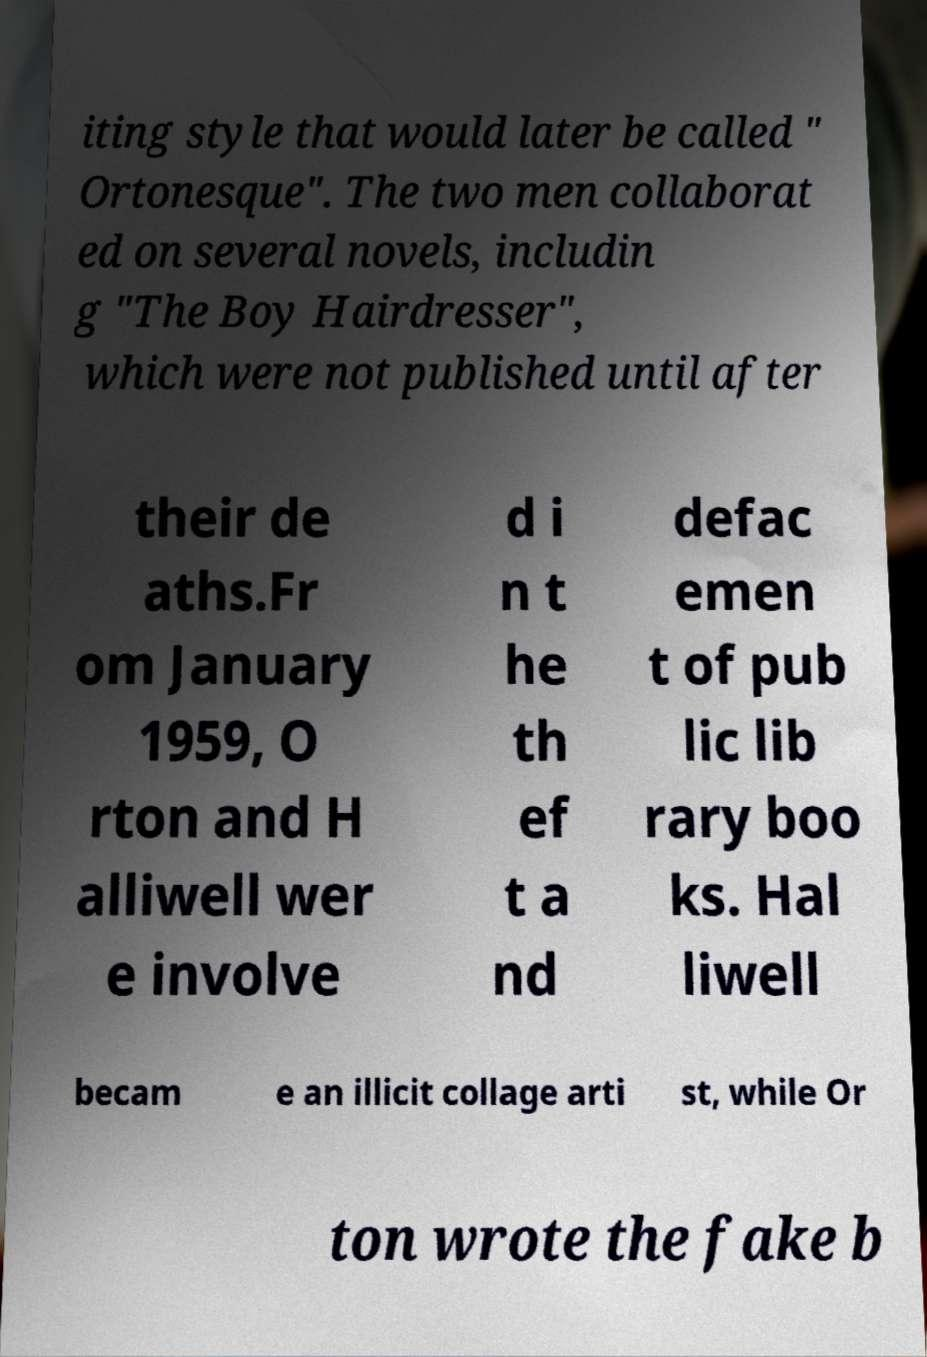Please identify and transcribe the text found in this image. iting style that would later be called " Ortonesque". The two men collaborat ed on several novels, includin g "The Boy Hairdresser", which were not published until after their de aths.Fr om January 1959, O rton and H alliwell wer e involve d i n t he th ef t a nd defac emen t of pub lic lib rary boo ks. Hal liwell becam e an illicit collage arti st, while Or ton wrote the fake b 